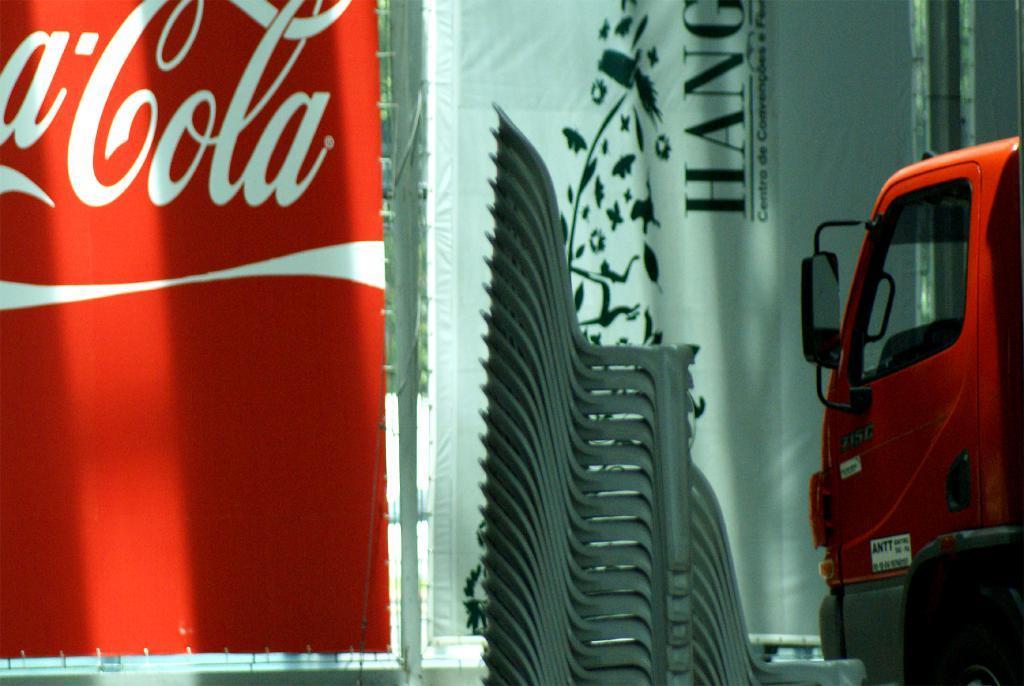Can you describe this image briefly? In this image I can see on the left side it looks like a banner in red color. In the middle there are chairs, on the right side there is a vehicle. 